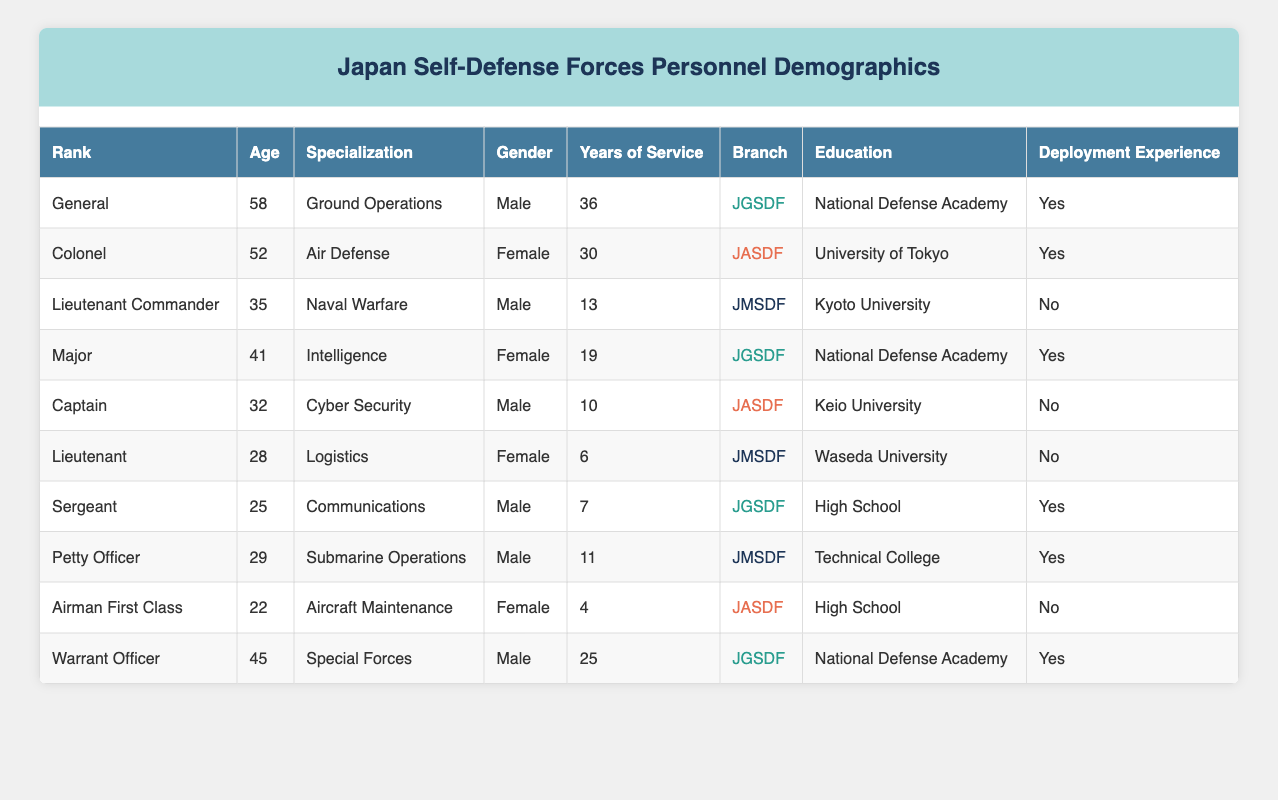What is the age of the General in the table? The General in the table has an age of 58, as directly listed in the Age column for the rank of General.
Answer: 58 How many personnel have deployment experience? By examining each row in the Deployment Experience column, I find there are 5 personnel listed with 'Yes' for deployment experience.
Answer: 5 What is the average age of personnel in the JGSDF branch? The ages of personnel in the JGSDF are 58 (General), 41 (Major), 25 (Sergeant), and 45 (Warrant Officer). Adding these gives 58 + 41 + 25 + 45 = 169. There are 4 personnel, so the average age is 169/4 = 42.25.
Answer: 42.25 Is there a female officer in the JASDF branch? By checking the Gender column for the JASDF branch, there is indeed one female officer: a Colonel, as indicated by her gender.
Answer: Yes What rank has the highest average years of service? Analyzing the years of service for each rank, the average years are calculated as follows: General (36), Colonel (30), Lieutenant Commander (13), Major (19), Captain (10), Lieutenant (6), Sergeant (7), Petty Officer (11), Airman First Class (4), and Warrant Officer (25). The General has the highest years of service at 36.
Answer: General How many personnel have a specialization in Cyber Security and are male? There is one male personnel who specializes in Cyber Security, identified as Captain in the table.
Answer: 1 What is the total years of service for all personnel in the table? Summing all the years of service: 36 (General) + 30 (Colonel) + 13 (Lieutenant Commander) + 19 (Major) + 10 (Captain) + 6 (Lieutenant) + 7 (Sergeant) + 11 (Petty Officer) + 4 (Airman First Class) + 25 (Warrant Officer) totals to 36 + 30 + 13 + 19 + 10 + 6 + 7 + 11 + 4 + 25 =  171.
Answer: 171 Are there more males than females in the JGSDF branch? In the JGSDF branch, we see three male officers (General, Sergeant, Warrant Officer) and one female officer (Major). Therefore, there are more males than females in this branch.
Answer: Yes What is the most common education level among the personnel listed? In the dataset, the education levels are: National Defense Academy (3), University of Tokyo (1), Kyoto University (1), Keio University (1), Waseda University (1), and High School (2). National Defense Academy has the highest occurrence with three personnel.
Answer: National Defense Academy 